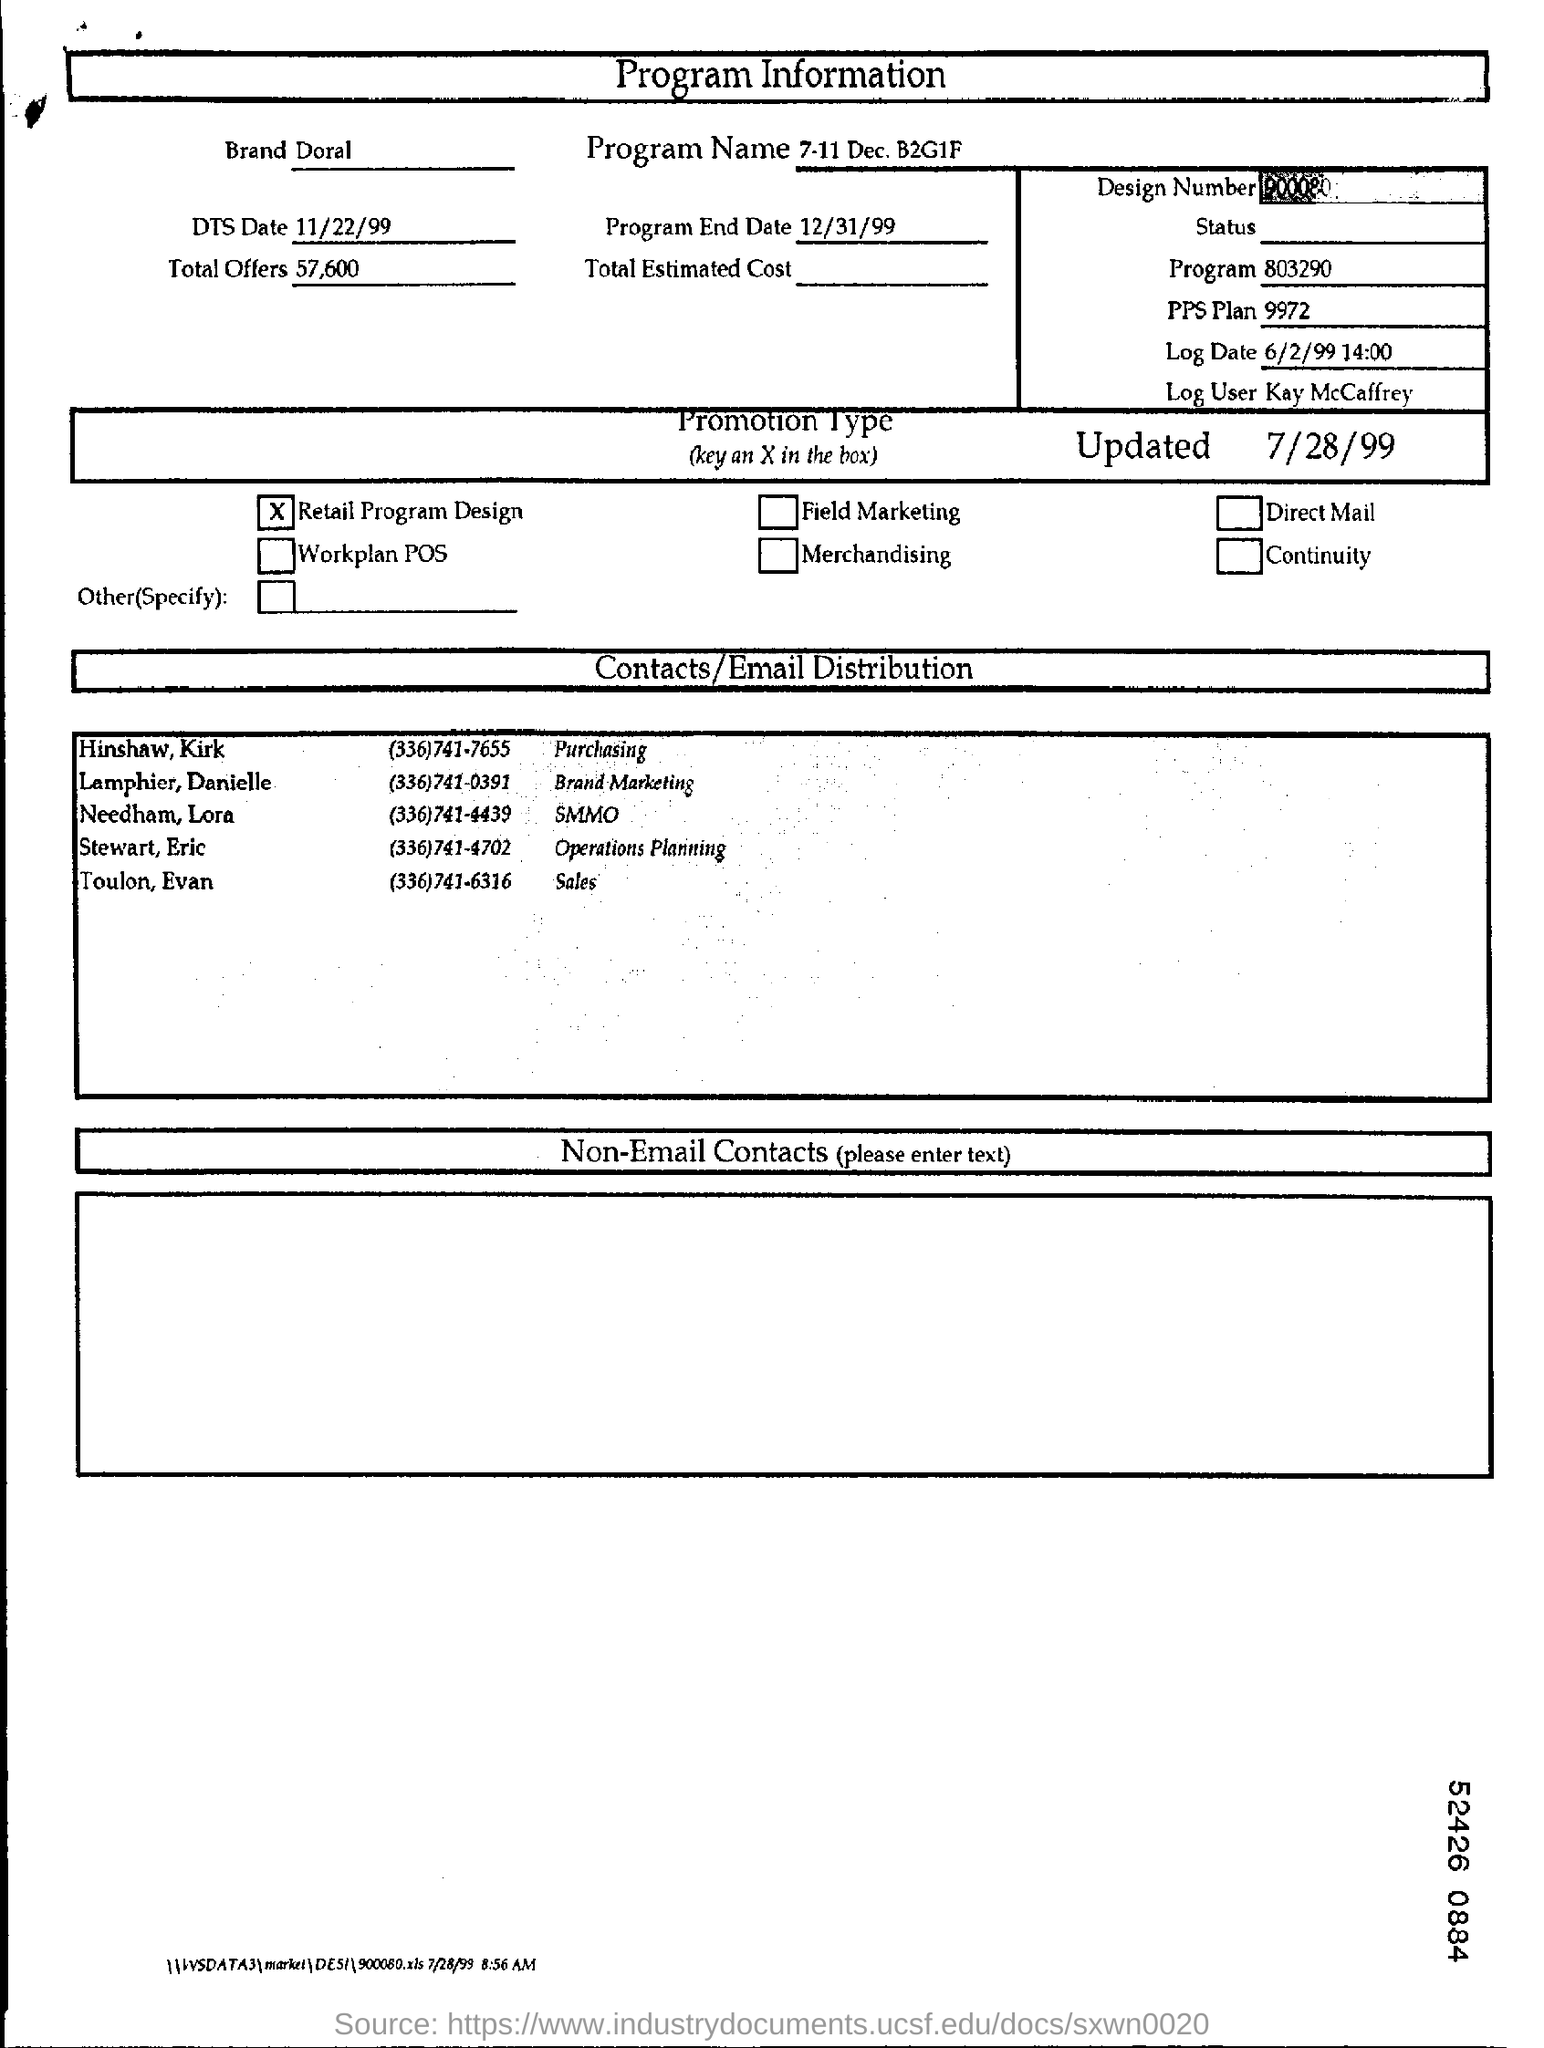Which brand is mentioned in the form?
Your answer should be very brief. Doral. What is the program name?
Provide a succinct answer. 7-11 dec, B2G1F. What is the DTS Date?
Ensure brevity in your answer.  11/22/99. Who is the log user?
Make the answer very short. Kay McCaffrey. How many total offers are there?
Your answer should be compact. 57,600. What is the type of promotion?
Give a very brief answer. Retail Program Design. 